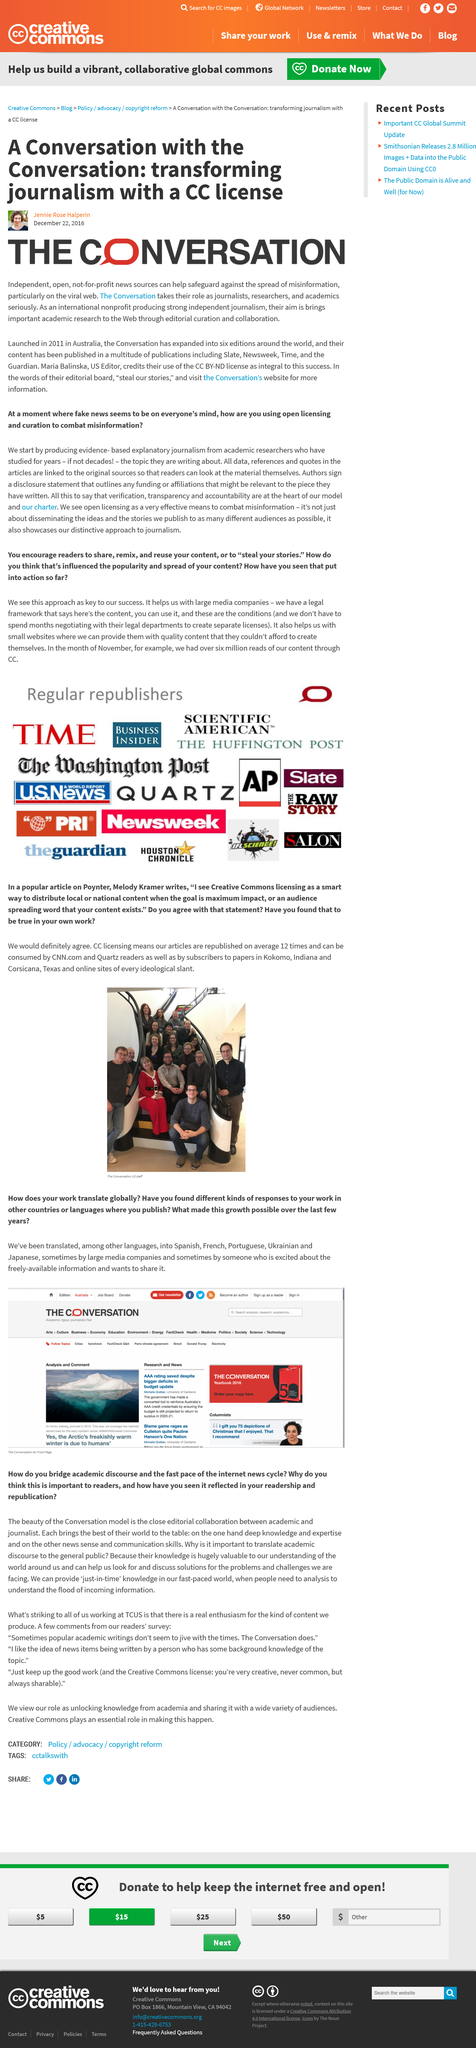Highlight a few significant elements in this photo. In our fast-paced world, we can provide "just-in-time" knowledge that is relevant and timely to meet the demands of a constantly changing environment. The Conversation was launched in the year 2011. Pauline Hanson's former party member, Culleton, has resigned from the party. The picture of the iceberg was taken in 2015, as indicated by the year shown in the image. The Conversation has expanded into six editions. 